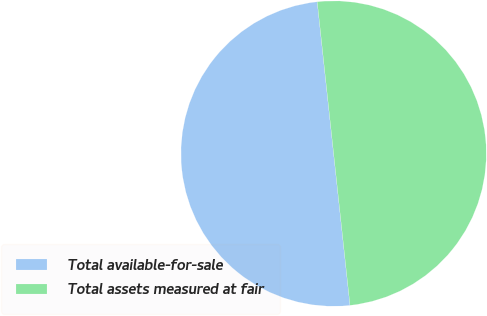<chart> <loc_0><loc_0><loc_500><loc_500><pie_chart><fcel>Total available-for-sale<fcel>Total assets measured at fair<nl><fcel>50.0%<fcel>50.0%<nl></chart> 